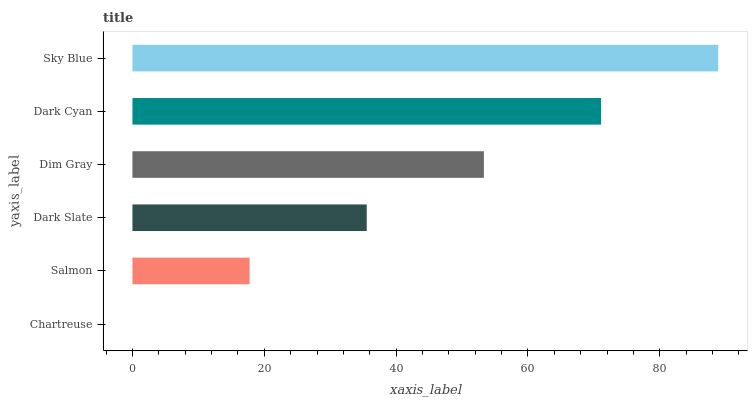Is Chartreuse the minimum?
Answer yes or no. Yes. Is Sky Blue the maximum?
Answer yes or no. Yes. Is Salmon the minimum?
Answer yes or no. No. Is Salmon the maximum?
Answer yes or no. No. Is Salmon greater than Chartreuse?
Answer yes or no. Yes. Is Chartreuse less than Salmon?
Answer yes or no. Yes. Is Chartreuse greater than Salmon?
Answer yes or no. No. Is Salmon less than Chartreuse?
Answer yes or no. No. Is Dim Gray the high median?
Answer yes or no. Yes. Is Dark Slate the low median?
Answer yes or no. Yes. Is Dark Cyan the high median?
Answer yes or no. No. Is Chartreuse the low median?
Answer yes or no. No. 